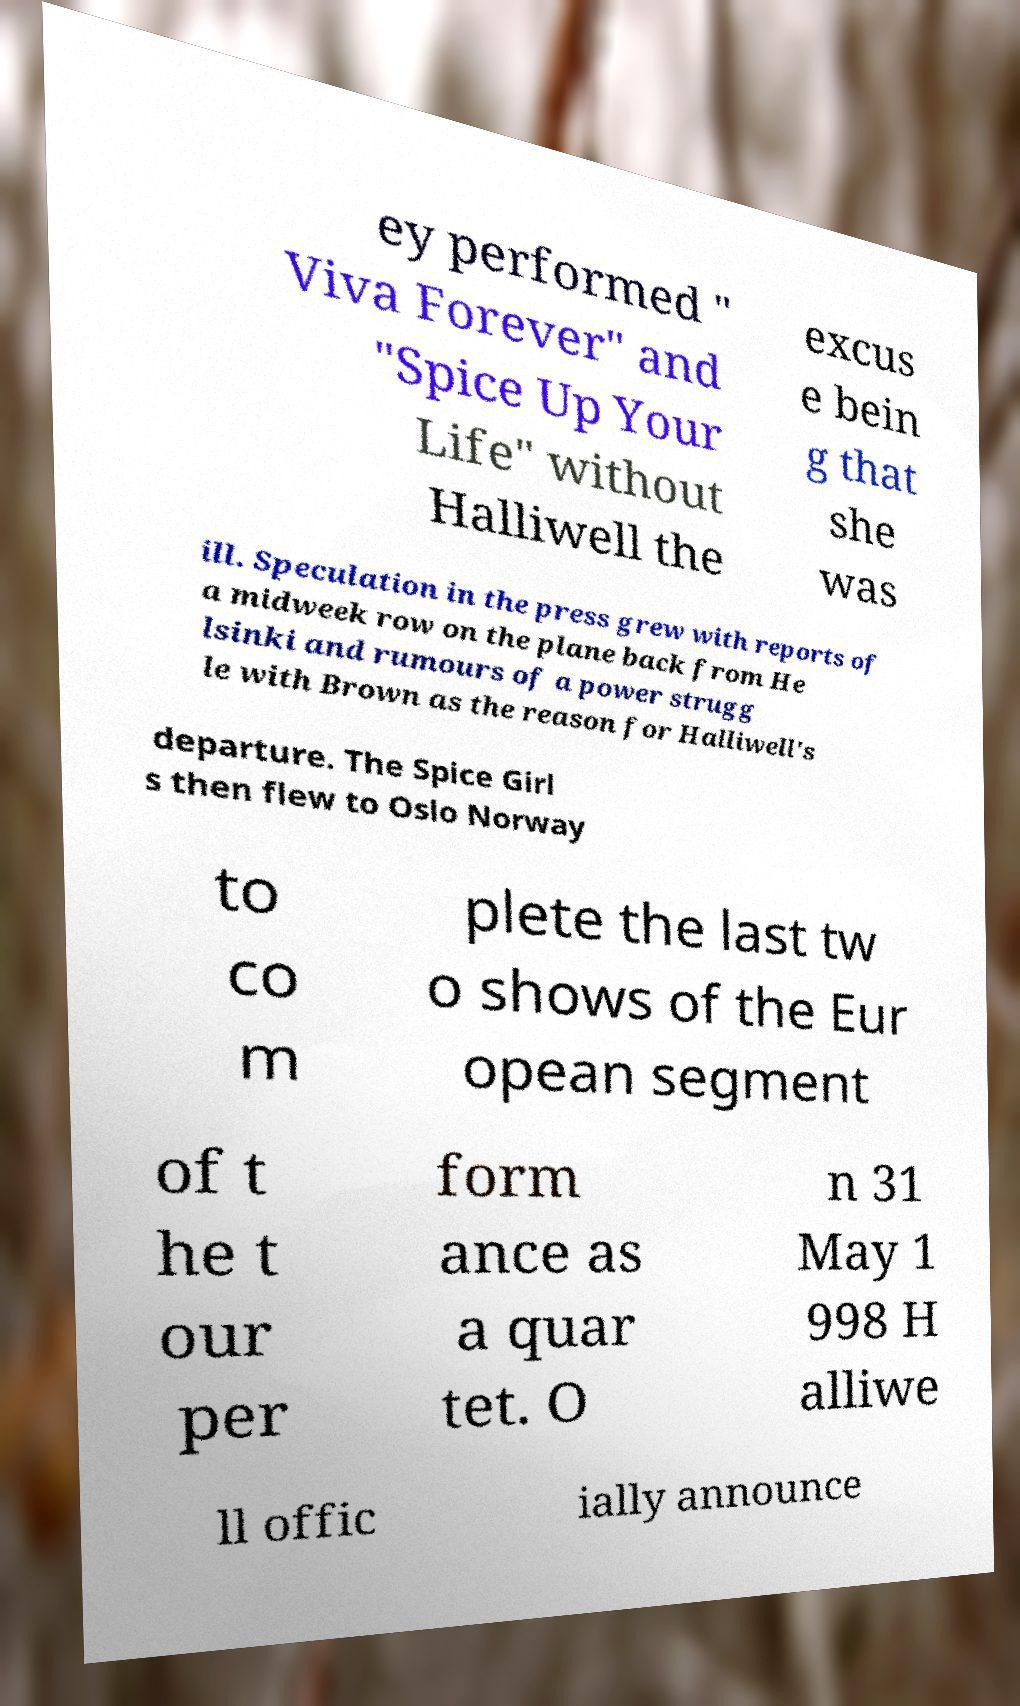Can you accurately transcribe the text from the provided image for me? ey performed " Viva Forever" and "Spice Up Your Life" without Halliwell the excus e bein g that she was ill. Speculation in the press grew with reports of a midweek row on the plane back from He lsinki and rumours of a power strugg le with Brown as the reason for Halliwell's departure. The Spice Girl s then flew to Oslo Norway to co m plete the last tw o shows of the Eur opean segment of t he t our per form ance as a quar tet. O n 31 May 1 998 H alliwe ll offic ially announce 